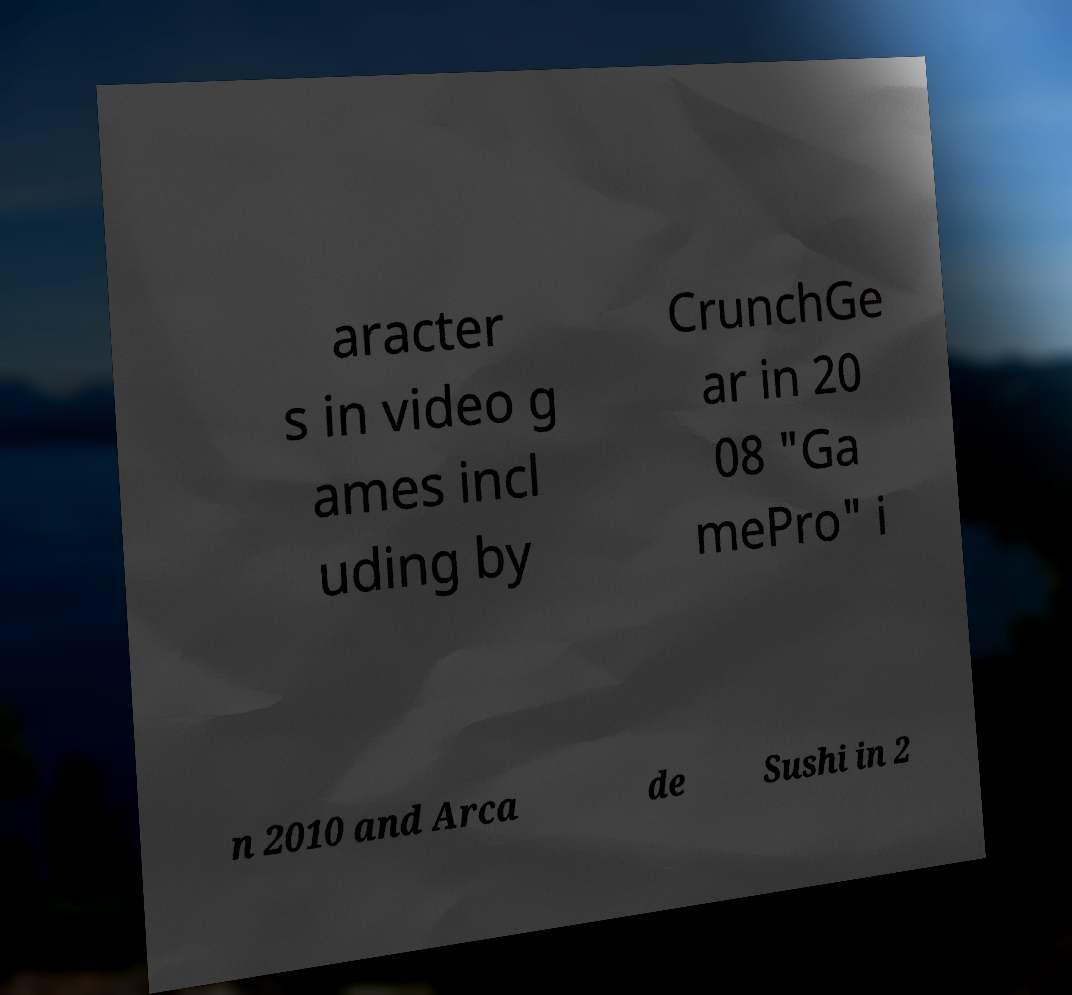Please read and relay the text visible in this image. What does it say? aracter s in video g ames incl uding by CrunchGe ar in 20 08 "Ga mePro" i n 2010 and Arca de Sushi in 2 